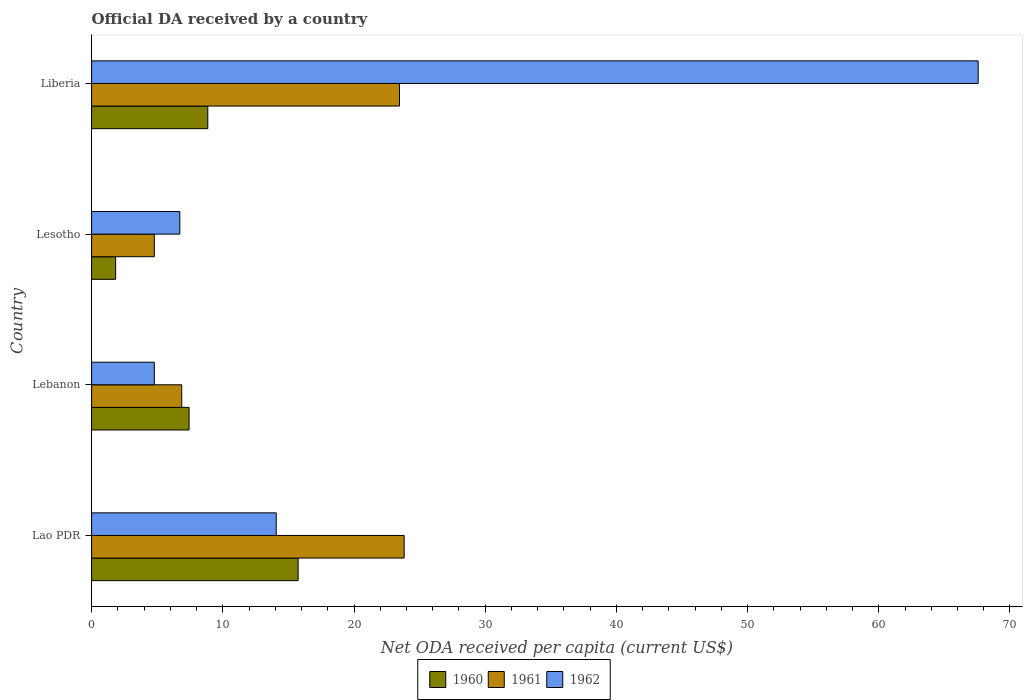How many groups of bars are there?
Give a very brief answer. 4. How many bars are there on the 1st tick from the top?
Your response must be concise. 3. What is the label of the 2nd group of bars from the top?
Offer a terse response. Lesotho. In how many cases, is the number of bars for a given country not equal to the number of legend labels?
Offer a terse response. 0. What is the ODA received in in 1962 in Lao PDR?
Your answer should be very brief. 14.07. Across all countries, what is the maximum ODA received in in 1961?
Offer a very short reply. 23.82. Across all countries, what is the minimum ODA received in in 1960?
Make the answer very short. 1.83. In which country was the ODA received in in 1961 maximum?
Your response must be concise. Lao PDR. In which country was the ODA received in in 1961 minimum?
Offer a very short reply. Lesotho. What is the total ODA received in in 1961 in the graph?
Give a very brief answer. 58.94. What is the difference between the ODA received in in 1962 in Lao PDR and that in Lesotho?
Your answer should be very brief. 7.35. What is the difference between the ODA received in in 1961 in Lesotho and the ODA received in in 1962 in Lebanon?
Keep it short and to the point. 0. What is the average ODA received in in 1961 per country?
Provide a succinct answer. 14.74. What is the difference between the ODA received in in 1960 and ODA received in in 1961 in Lebanon?
Provide a short and direct response. 0.56. What is the ratio of the ODA received in in 1960 in Lebanon to that in Lesotho?
Your answer should be very brief. 4.05. What is the difference between the highest and the second highest ODA received in in 1962?
Offer a terse response. 53.5. What is the difference between the highest and the lowest ODA received in in 1962?
Provide a succinct answer. 62.8. In how many countries, is the ODA received in in 1962 greater than the average ODA received in in 1962 taken over all countries?
Keep it short and to the point. 1. What does the 1st bar from the top in Lao PDR represents?
Make the answer very short. 1962. Is it the case that in every country, the sum of the ODA received in in 1961 and ODA received in in 1960 is greater than the ODA received in in 1962?
Provide a short and direct response. No. What is the difference between two consecutive major ticks on the X-axis?
Your response must be concise. 10. Where does the legend appear in the graph?
Your answer should be very brief. Bottom center. How are the legend labels stacked?
Give a very brief answer. Horizontal. What is the title of the graph?
Offer a very short reply. Official DA received by a country. What is the label or title of the X-axis?
Offer a very short reply. Net ODA received per capita (current US$). What is the label or title of the Y-axis?
Provide a short and direct response. Country. What is the Net ODA received per capita (current US$) in 1960 in Lao PDR?
Your response must be concise. 15.74. What is the Net ODA received per capita (current US$) in 1961 in Lao PDR?
Provide a short and direct response. 23.82. What is the Net ODA received per capita (current US$) of 1962 in Lao PDR?
Provide a short and direct response. 14.07. What is the Net ODA received per capita (current US$) in 1960 in Lebanon?
Give a very brief answer. 7.43. What is the Net ODA received per capita (current US$) of 1961 in Lebanon?
Your response must be concise. 6.87. What is the Net ODA received per capita (current US$) in 1962 in Lebanon?
Your response must be concise. 4.78. What is the Net ODA received per capita (current US$) of 1960 in Lesotho?
Make the answer very short. 1.83. What is the Net ODA received per capita (current US$) in 1961 in Lesotho?
Provide a short and direct response. 4.78. What is the Net ODA received per capita (current US$) in 1962 in Lesotho?
Your answer should be compact. 6.72. What is the Net ODA received per capita (current US$) in 1960 in Liberia?
Your response must be concise. 8.85. What is the Net ODA received per capita (current US$) of 1961 in Liberia?
Your answer should be very brief. 23.47. What is the Net ODA received per capita (current US$) in 1962 in Liberia?
Offer a terse response. 67.57. Across all countries, what is the maximum Net ODA received per capita (current US$) of 1960?
Your answer should be very brief. 15.74. Across all countries, what is the maximum Net ODA received per capita (current US$) in 1961?
Provide a short and direct response. 23.82. Across all countries, what is the maximum Net ODA received per capita (current US$) of 1962?
Your answer should be very brief. 67.57. Across all countries, what is the minimum Net ODA received per capita (current US$) in 1960?
Offer a terse response. 1.83. Across all countries, what is the minimum Net ODA received per capita (current US$) of 1961?
Provide a short and direct response. 4.78. Across all countries, what is the minimum Net ODA received per capita (current US$) of 1962?
Make the answer very short. 4.78. What is the total Net ODA received per capita (current US$) of 1960 in the graph?
Keep it short and to the point. 33.86. What is the total Net ODA received per capita (current US$) of 1961 in the graph?
Offer a terse response. 58.94. What is the total Net ODA received per capita (current US$) in 1962 in the graph?
Ensure brevity in your answer.  93.15. What is the difference between the Net ODA received per capita (current US$) of 1960 in Lao PDR and that in Lebanon?
Give a very brief answer. 8.31. What is the difference between the Net ODA received per capita (current US$) in 1961 in Lao PDR and that in Lebanon?
Ensure brevity in your answer.  16.95. What is the difference between the Net ODA received per capita (current US$) of 1962 in Lao PDR and that in Lebanon?
Your answer should be compact. 9.29. What is the difference between the Net ODA received per capita (current US$) in 1960 in Lao PDR and that in Lesotho?
Offer a very short reply. 13.91. What is the difference between the Net ODA received per capita (current US$) of 1961 in Lao PDR and that in Lesotho?
Ensure brevity in your answer.  19.04. What is the difference between the Net ODA received per capita (current US$) of 1962 in Lao PDR and that in Lesotho?
Make the answer very short. 7.35. What is the difference between the Net ODA received per capita (current US$) in 1960 in Lao PDR and that in Liberia?
Provide a succinct answer. 6.89. What is the difference between the Net ODA received per capita (current US$) in 1961 in Lao PDR and that in Liberia?
Ensure brevity in your answer.  0.35. What is the difference between the Net ODA received per capita (current US$) of 1962 in Lao PDR and that in Liberia?
Keep it short and to the point. -53.5. What is the difference between the Net ODA received per capita (current US$) of 1960 in Lebanon and that in Lesotho?
Your answer should be compact. 5.6. What is the difference between the Net ODA received per capita (current US$) of 1961 in Lebanon and that in Lesotho?
Keep it short and to the point. 2.09. What is the difference between the Net ODA received per capita (current US$) of 1962 in Lebanon and that in Lesotho?
Your answer should be very brief. -1.95. What is the difference between the Net ODA received per capita (current US$) in 1960 in Lebanon and that in Liberia?
Ensure brevity in your answer.  -1.43. What is the difference between the Net ODA received per capita (current US$) in 1961 in Lebanon and that in Liberia?
Offer a terse response. -16.6. What is the difference between the Net ODA received per capita (current US$) of 1962 in Lebanon and that in Liberia?
Offer a very short reply. -62.8. What is the difference between the Net ODA received per capita (current US$) of 1960 in Lesotho and that in Liberia?
Your answer should be very brief. -7.02. What is the difference between the Net ODA received per capita (current US$) in 1961 in Lesotho and that in Liberia?
Provide a short and direct response. -18.69. What is the difference between the Net ODA received per capita (current US$) in 1962 in Lesotho and that in Liberia?
Ensure brevity in your answer.  -60.85. What is the difference between the Net ODA received per capita (current US$) in 1960 in Lao PDR and the Net ODA received per capita (current US$) in 1961 in Lebanon?
Your answer should be compact. 8.87. What is the difference between the Net ODA received per capita (current US$) of 1960 in Lao PDR and the Net ODA received per capita (current US$) of 1962 in Lebanon?
Offer a terse response. 10.96. What is the difference between the Net ODA received per capita (current US$) of 1961 in Lao PDR and the Net ODA received per capita (current US$) of 1962 in Lebanon?
Your answer should be compact. 19.05. What is the difference between the Net ODA received per capita (current US$) of 1960 in Lao PDR and the Net ODA received per capita (current US$) of 1961 in Lesotho?
Your response must be concise. 10.96. What is the difference between the Net ODA received per capita (current US$) of 1960 in Lao PDR and the Net ODA received per capita (current US$) of 1962 in Lesotho?
Provide a short and direct response. 9.02. What is the difference between the Net ODA received per capita (current US$) of 1961 in Lao PDR and the Net ODA received per capita (current US$) of 1962 in Lesotho?
Offer a very short reply. 17.1. What is the difference between the Net ODA received per capita (current US$) of 1960 in Lao PDR and the Net ODA received per capita (current US$) of 1961 in Liberia?
Ensure brevity in your answer.  -7.73. What is the difference between the Net ODA received per capita (current US$) in 1960 in Lao PDR and the Net ODA received per capita (current US$) in 1962 in Liberia?
Keep it short and to the point. -51.83. What is the difference between the Net ODA received per capita (current US$) in 1961 in Lao PDR and the Net ODA received per capita (current US$) in 1962 in Liberia?
Keep it short and to the point. -43.75. What is the difference between the Net ODA received per capita (current US$) of 1960 in Lebanon and the Net ODA received per capita (current US$) of 1961 in Lesotho?
Ensure brevity in your answer.  2.65. What is the difference between the Net ODA received per capita (current US$) of 1960 in Lebanon and the Net ODA received per capita (current US$) of 1962 in Lesotho?
Keep it short and to the point. 0.71. What is the difference between the Net ODA received per capita (current US$) of 1961 in Lebanon and the Net ODA received per capita (current US$) of 1962 in Lesotho?
Provide a succinct answer. 0.15. What is the difference between the Net ODA received per capita (current US$) in 1960 in Lebanon and the Net ODA received per capita (current US$) in 1961 in Liberia?
Provide a short and direct response. -16.04. What is the difference between the Net ODA received per capita (current US$) in 1960 in Lebanon and the Net ODA received per capita (current US$) in 1962 in Liberia?
Ensure brevity in your answer.  -60.14. What is the difference between the Net ODA received per capita (current US$) of 1961 in Lebanon and the Net ODA received per capita (current US$) of 1962 in Liberia?
Make the answer very short. -60.7. What is the difference between the Net ODA received per capita (current US$) of 1960 in Lesotho and the Net ODA received per capita (current US$) of 1961 in Liberia?
Ensure brevity in your answer.  -21.64. What is the difference between the Net ODA received per capita (current US$) of 1960 in Lesotho and the Net ODA received per capita (current US$) of 1962 in Liberia?
Make the answer very short. -65.74. What is the difference between the Net ODA received per capita (current US$) in 1961 in Lesotho and the Net ODA received per capita (current US$) in 1962 in Liberia?
Keep it short and to the point. -62.8. What is the average Net ODA received per capita (current US$) in 1960 per country?
Offer a very short reply. 8.46. What is the average Net ODA received per capita (current US$) of 1961 per country?
Ensure brevity in your answer.  14.74. What is the average Net ODA received per capita (current US$) of 1962 per country?
Make the answer very short. 23.29. What is the difference between the Net ODA received per capita (current US$) of 1960 and Net ODA received per capita (current US$) of 1961 in Lao PDR?
Your answer should be compact. -8.08. What is the difference between the Net ODA received per capita (current US$) in 1960 and Net ODA received per capita (current US$) in 1962 in Lao PDR?
Your answer should be very brief. 1.67. What is the difference between the Net ODA received per capita (current US$) in 1961 and Net ODA received per capita (current US$) in 1962 in Lao PDR?
Make the answer very short. 9.75. What is the difference between the Net ODA received per capita (current US$) of 1960 and Net ODA received per capita (current US$) of 1961 in Lebanon?
Provide a short and direct response. 0.56. What is the difference between the Net ODA received per capita (current US$) of 1960 and Net ODA received per capita (current US$) of 1962 in Lebanon?
Ensure brevity in your answer.  2.65. What is the difference between the Net ODA received per capita (current US$) in 1961 and Net ODA received per capita (current US$) in 1962 in Lebanon?
Your response must be concise. 2.09. What is the difference between the Net ODA received per capita (current US$) of 1960 and Net ODA received per capita (current US$) of 1961 in Lesotho?
Give a very brief answer. -2.95. What is the difference between the Net ODA received per capita (current US$) of 1960 and Net ODA received per capita (current US$) of 1962 in Lesotho?
Provide a succinct answer. -4.89. What is the difference between the Net ODA received per capita (current US$) of 1961 and Net ODA received per capita (current US$) of 1962 in Lesotho?
Make the answer very short. -1.94. What is the difference between the Net ODA received per capita (current US$) of 1960 and Net ODA received per capita (current US$) of 1961 in Liberia?
Offer a terse response. -14.61. What is the difference between the Net ODA received per capita (current US$) in 1960 and Net ODA received per capita (current US$) in 1962 in Liberia?
Keep it short and to the point. -58.72. What is the difference between the Net ODA received per capita (current US$) of 1961 and Net ODA received per capita (current US$) of 1962 in Liberia?
Your answer should be compact. -44.1. What is the ratio of the Net ODA received per capita (current US$) in 1960 in Lao PDR to that in Lebanon?
Provide a succinct answer. 2.12. What is the ratio of the Net ODA received per capita (current US$) of 1961 in Lao PDR to that in Lebanon?
Make the answer very short. 3.47. What is the ratio of the Net ODA received per capita (current US$) in 1962 in Lao PDR to that in Lebanon?
Offer a terse response. 2.94. What is the ratio of the Net ODA received per capita (current US$) in 1960 in Lao PDR to that in Lesotho?
Your response must be concise. 8.59. What is the ratio of the Net ODA received per capita (current US$) in 1961 in Lao PDR to that in Lesotho?
Provide a succinct answer. 4.98. What is the ratio of the Net ODA received per capita (current US$) of 1962 in Lao PDR to that in Lesotho?
Offer a terse response. 2.09. What is the ratio of the Net ODA received per capita (current US$) in 1960 in Lao PDR to that in Liberia?
Offer a terse response. 1.78. What is the ratio of the Net ODA received per capita (current US$) of 1961 in Lao PDR to that in Liberia?
Provide a short and direct response. 1.02. What is the ratio of the Net ODA received per capita (current US$) in 1962 in Lao PDR to that in Liberia?
Offer a very short reply. 0.21. What is the ratio of the Net ODA received per capita (current US$) in 1960 in Lebanon to that in Lesotho?
Give a very brief answer. 4.05. What is the ratio of the Net ODA received per capita (current US$) in 1961 in Lebanon to that in Lesotho?
Your response must be concise. 1.44. What is the ratio of the Net ODA received per capita (current US$) of 1962 in Lebanon to that in Lesotho?
Offer a very short reply. 0.71. What is the ratio of the Net ODA received per capita (current US$) in 1960 in Lebanon to that in Liberia?
Your answer should be compact. 0.84. What is the ratio of the Net ODA received per capita (current US$) in 1961 in Lebanon to that in Liberia?
Provide a short and direct response. 0.29. What is the ratio of the Net ODA received per capita (current US$) in 1962 in Lebanon to that in Liberia?
Offer a terse response. 0.07. What is the ratio of the Net ODA received per capita (current US$) of 1960 in Lesotho to that in Liberia?
Provide a succinct answer. 0.21. What is the ratio of the Net ODA received per capita (current US$) in 1961 in Lesotho to that in Liberia?
Offer a terse response. 0.2. What is the ratio of the Net ODA received per capita (current US$) in 1962 in Lesotho to that in Liberia?
Your response must be concise. 0.1. What is the difference between the highest and the second highest Net ODA received per capita (current US$) in 1960?
Ensure brevity in your answer.  6.89. What is the difference between the highest and the second highest Net ODA received per capita (current US$) of 1961?
Provide a short and direct response. 0.35. What is the difference between the highest and the second highest Net ODA received per capita (current US$) of 1962?
Your answer should be very brief. 53.5. What is the difference between the highest and the lowest Net ODA received per capita (current US$) of 1960?
Keep it short and to the point. 13.91. What is the difference between the highest and the lowest Net ODA received per capita (current US$) of 1961?
Provide a short and direct response. 19.04. What is the difference between the highest and the lowest Net ODA received per capita (current US$) of 1962?
Provide a succinct answer. 62.8. 